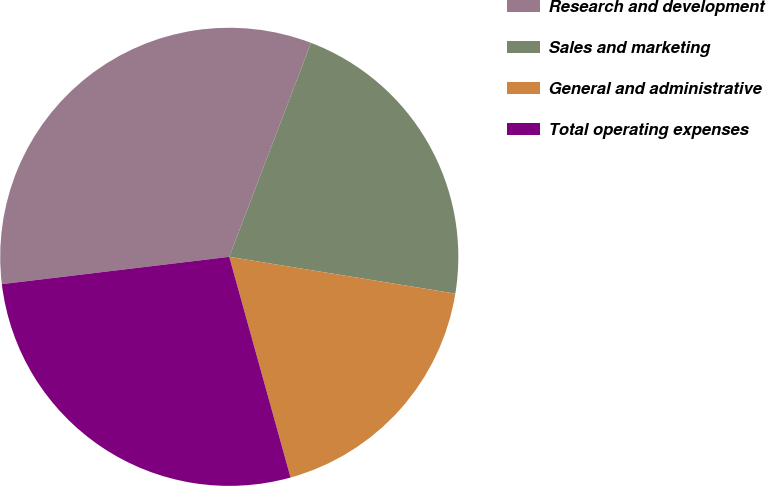Convert chart. <chart><loc_0><loc_0><loc_500><loc_500><pie_chart><fcel>Research and development<fcel>Sales and marketing<fcel>General and administrative<fcel>Total operating expenses<nl><fcel>32.71%<fcel>21.76%<fcel>18.12%<fcel>27.41%<nl></chart> 